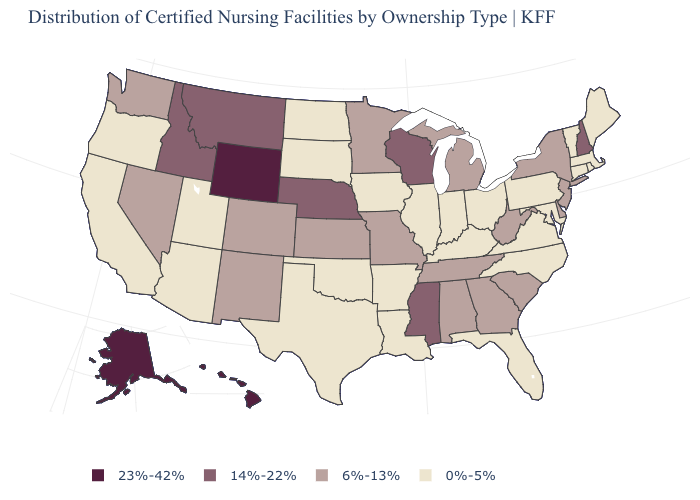What is the value of Maryland?
Quick response, please. 0%-5%. Name the states that have a value in the range 6%-13%?
Concise answer only. Alabama, Colorado, Delaware, Georgia, Kansas, Michigan, Minnesota, Missouri, Nevada, New Jersey, New Mexico, New York, South Carolina, Tennessee, Washington, West Virginia. What is the value of Washington?
Give a very brief answer. 6%-13%. Which states have the lowest value in the USA?
Quick response, please. Arizona, Arkansas, California, Connecticut, Florida, Illinois, Indiana, Iowa, Kentucky, Louisiana, Maine, Maryland, Massachusetts, North Carolina, North Dakota, Ohio, Oklahoma, Oregon, Pennsylvania, Rhode Island, South Dakota, Texas, Utah, Vermont, Virginia. Is the legend a continuous bar?
Keep it brief. No. Name the states that have a value in the range 0%-5%?
Short answer required. Arizona, Arkansas, California, Connecticut, Florida, Illinois, Indiana, Iowa, Kentucky, Louisiana, Maine, Maryland, Massachusetts, North Carolina, North Dakota, Ohio, Oklahoma, Oregon, Pennsylvania, Rhode Island, South Dakota, Texas, Utah, Vermont, Virginia. What is the value of Tennessee?
Give a very brief answer. 6%-13%. What is the value of North Carolina?
Be succinct. 0%-5%. What is the value of Alaska?
Be succinct. 23%-42%. What is the highest value in the MidWest ?
Write a very short answer. 14%-22%. Among the states that border Wyoming , does Nebraska have the highest value?
Write a very short answer. Yes. Does Wyoming have a lower value than Tennessee?
Quick response, please. No. Which states hav the highest value in the West?
Be succinct. Alaska, Hawaii, Wyoming. Does Wyoming have a higher value than Iowa?
Concise answer only. Yes. What is the value of Florida?
Be succinct. 0%-5%. 